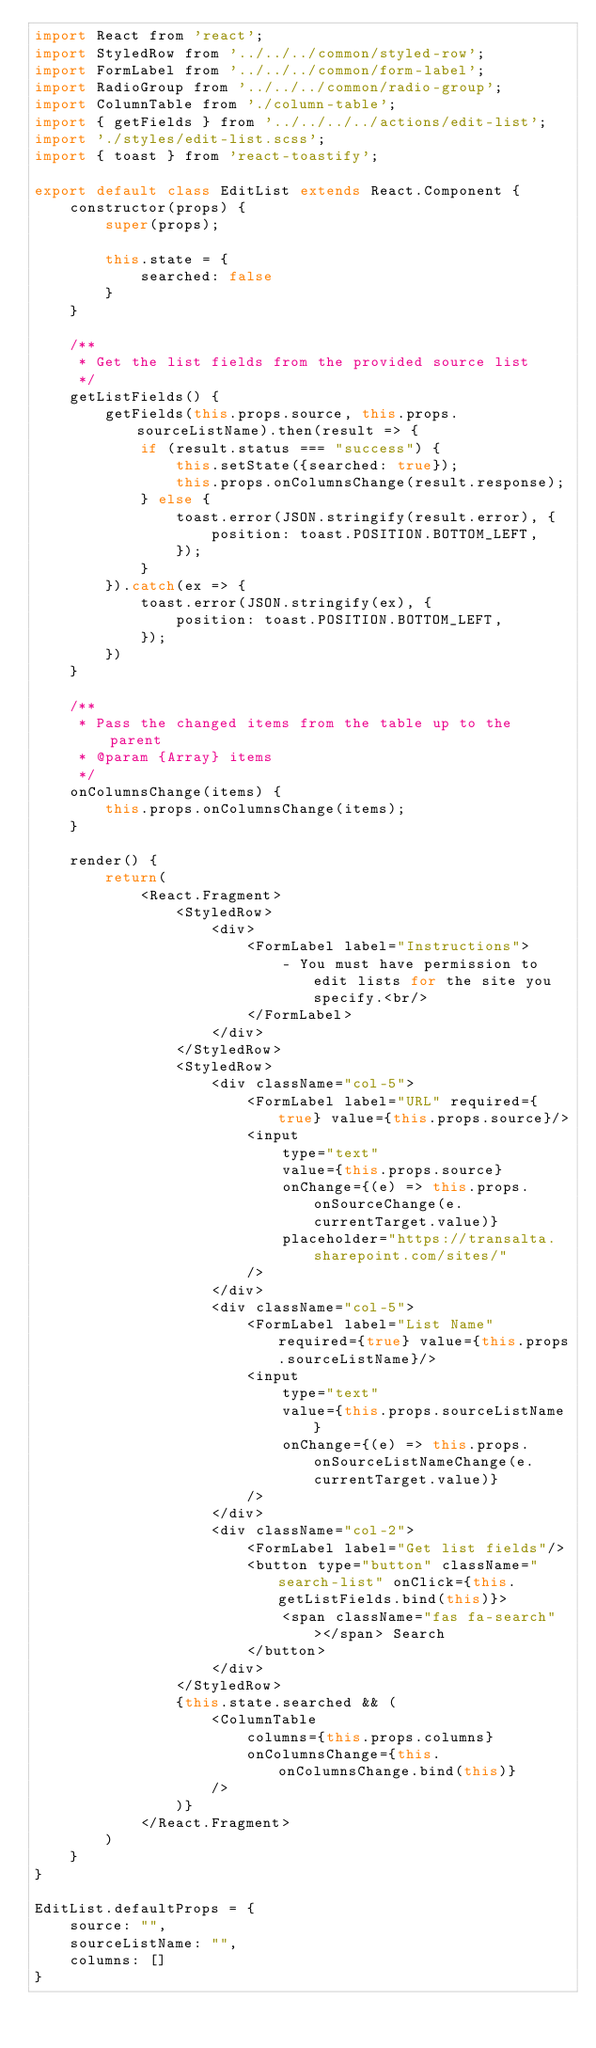<code> <loc_0><loc_0><loc_500><loc_500><_JavaScript_>import React from 'react';
import StyledRow from '../../../common/styled-row';
import FormLabel from '../../../common/form-label';
import RadioGroup from '../../../common/radio-group';
import ColumnTable from './column-table';
import { getFields } from '../../../../actions/edit-list';
import './styles/edit-list.scss';
import { toast } from 'react-toastify';

export default class EditList extends React.Component {
    constructor(props) {
        super(props);

        this.state = {
            searched: false
        }
    }

    /**
     * Get the list fields from the provided source list
     */
    getListFields() {
        getFields(this.props.source, this.props.sourceListName).then(result => {
            if (result.status === "success") {
                this.setState({searched: true});
                this.props.onColumnsChange(result.response);
            } else {
                toast.error(JSON.stringify(result.error), {
                    position: toast.POSITION.BOTTOM_LEFT,
                });
            }
        }).catch(ex => {
            toast.error(JSON.stringify(ex), {
                position: toast.POSITION.BOTTOM_LEFT,
            });
        })
    }

    /**
     * Pass the changed items from the table up to the parent
     * @param {Array} items 
     */
    onColumnsChange(items) {
        this.props.onColumnsChange(items);
    }

    render() {
        return(
            <React.Fragment>
                <StyledRow>
                    <div>
                        <FormLabel label="Instructions">
                            - You must have permission to edit lists for the site you specify.<br/>
                        </FormLabel>
                    </div>
                </StyledRow>
                <StyledRow>
                    <div className="col-5">
                        <FormLabel label="URL" required={true} value={this.props.source}/>
                        <input 
                            type="text" 
                            value={this.props.source} 
                            onChange={(e) => this.props.onSourceChange(e.currentTarget.value)}
                            placeholder="https://transalta.sharepoint.com/sites/"
                        />
                    </div>
                    <div className="col-5">
                        <FormLabel label="List Name" required={true} value={this.props.sourceListName}/>
                        <input 
                            type="text" 
                            value={this.props.sourceListName} 
                            onChange={(e) => this.props.onSourceListNameChange(e.currentTarget.value)}
                        />
                    </div>
                    <div className="col-2">
                        <FormLabel label="Get list fields"/>
                        <button type="button" className="search-list" onClick={this.getListFields.bind(this)}>
                            <span className="fas fa-search"></span> Search
                        </button>
                    </div>
                </StyledRow>
                {this.state.searched && (
                    <ColumnTable 
                        columns={this.props.columns}
                        onColumnsChange={this.onColumnsChange.bind(this)}
                    />
                )}
            </React.Fragment>
        )
    }
}

EditList.defaultProps = {
    source: "",
    sourceListName: "",
    columns: []
}</code> 